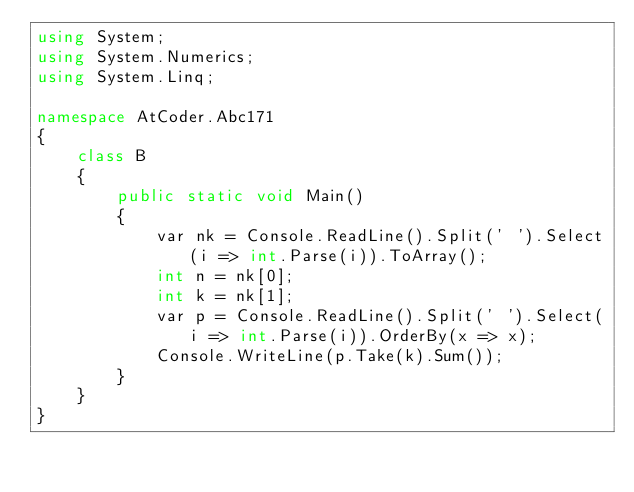<code> <loc_0><loc_0><loc_500><loc_500><_C#_>using System;
using System.Numerics;
using System.Linq;

namespace AtCoder.Abc171
{
    class B
    {
        public static void Main()
        {
            var nk = Console.ReadLine().Split(' ').Select(i => int.Parse(i)).ToArray();
            int n = nk[0];
            int k = nk[1];
            var p = Console.ReadLine().Split(' ').Select(i => int.Parse(i)).OrderBy(x => x);
            Console.WriteLine(p.Take(k).Sum());
        }
    }
}
</code> 